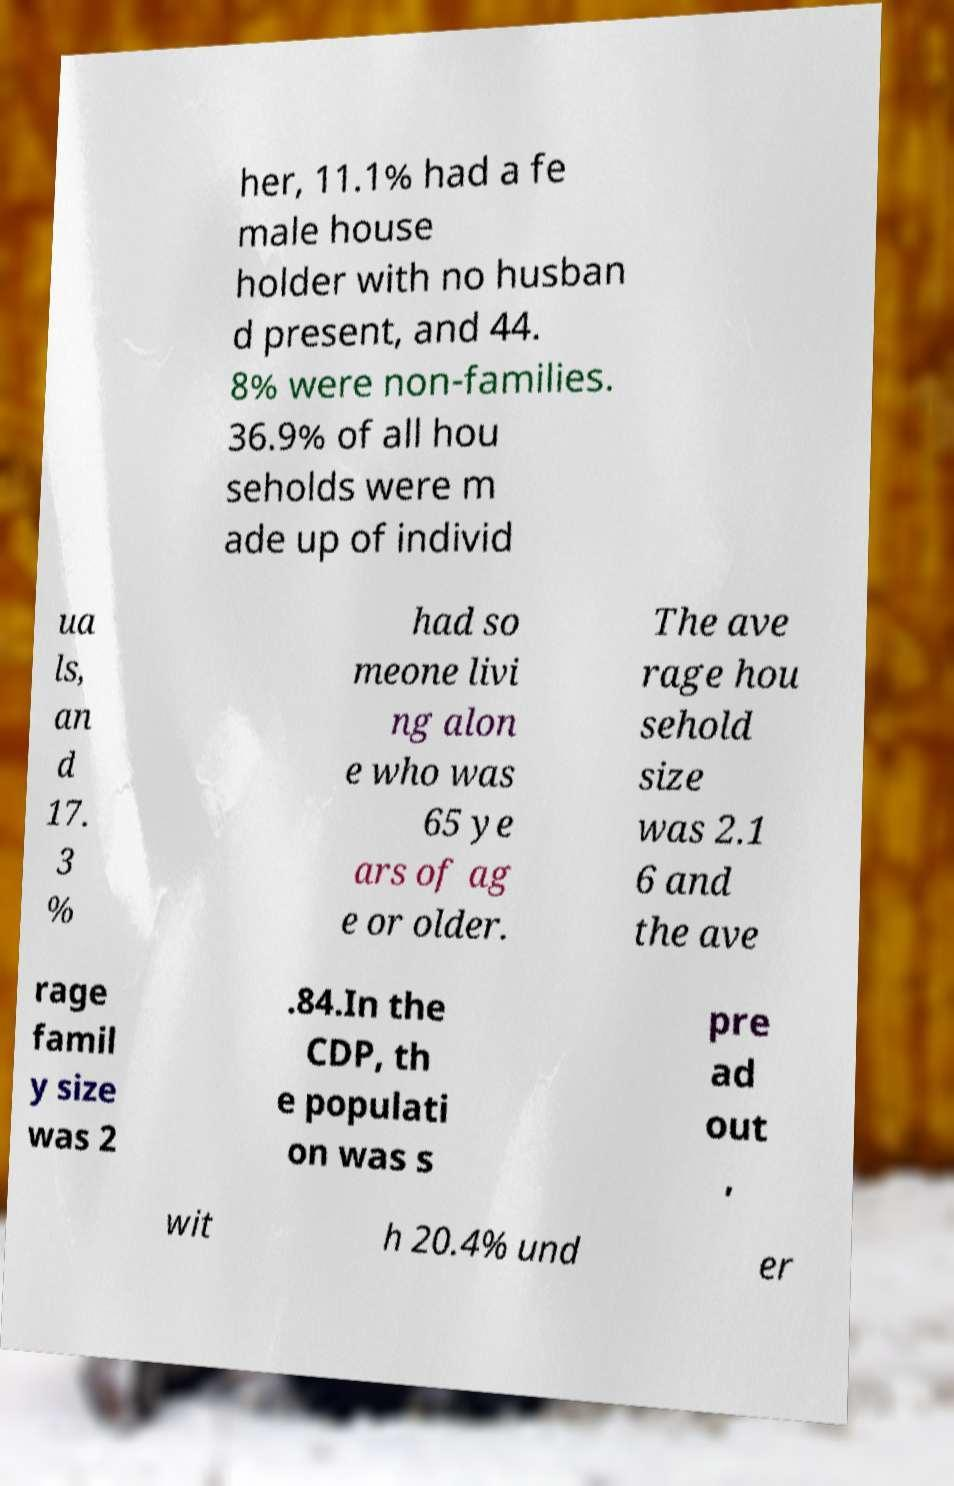There's text embedded in this image that I need extracted. Can you transcribe it verbatim? her, 11.1% had a fe male house holder with no husban d present, and 44. 8% were non-families. 36.9% of all hou seholds were m ade up of individ ua ls, an d 17. 3 % had so meone livi ng alon e who was 65 ye ars of ag e or older. The ave rage hou sehold size was 2.1 6 and the ave rage famil y size was 2 .84.In the CDP, th e populati on was s pre ad out , wit h 20.4% und er 